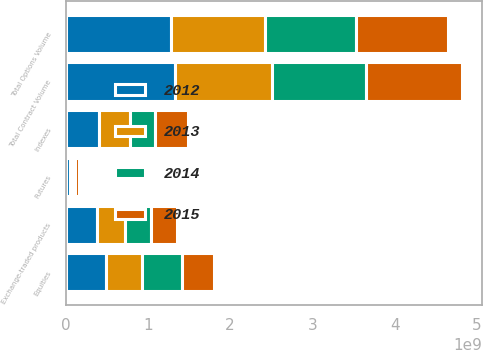<chart> <loc_0><loc_0><loc_500><loc_500><stacked_bar_chart><ecel><fcel>Equities<fcel>Indexes<fcel>Exchange-traded products<fcel>Total Options Volume<fcel>Futures<fcel>Total Contract Volume<nl><fcel>2015<fcel>3.92982e+08<fcel>4.08282e+08<fcel>3.20997e+08<fcel>1.12226e+09<fcel>5.16712e+07<fcel>1.17393e+09<nl><fcel>2012<fcel>4.88581e+08<fcel>4.06455e+08<fcel>3.79742e+08<fcel>1.27478e+09<fcel>5.06154e+07<fcel>1.32539e+09<nl><fcel>2013<fcel>4.33777e+08<fcel>3.72647e+08<fcel>3.41023e+08<fcel>1.14745e+09<fcel>4.01934e+07<fcel>1.18764e+09<nl><fcel>2014<fcel>4.94289e+08<fcel>3.0434e+08<fcel>3.11792e+08<fcel>1.11042e+09<fcel>2.38929e+07<fcel>1.13431e+09<nl></chart> 